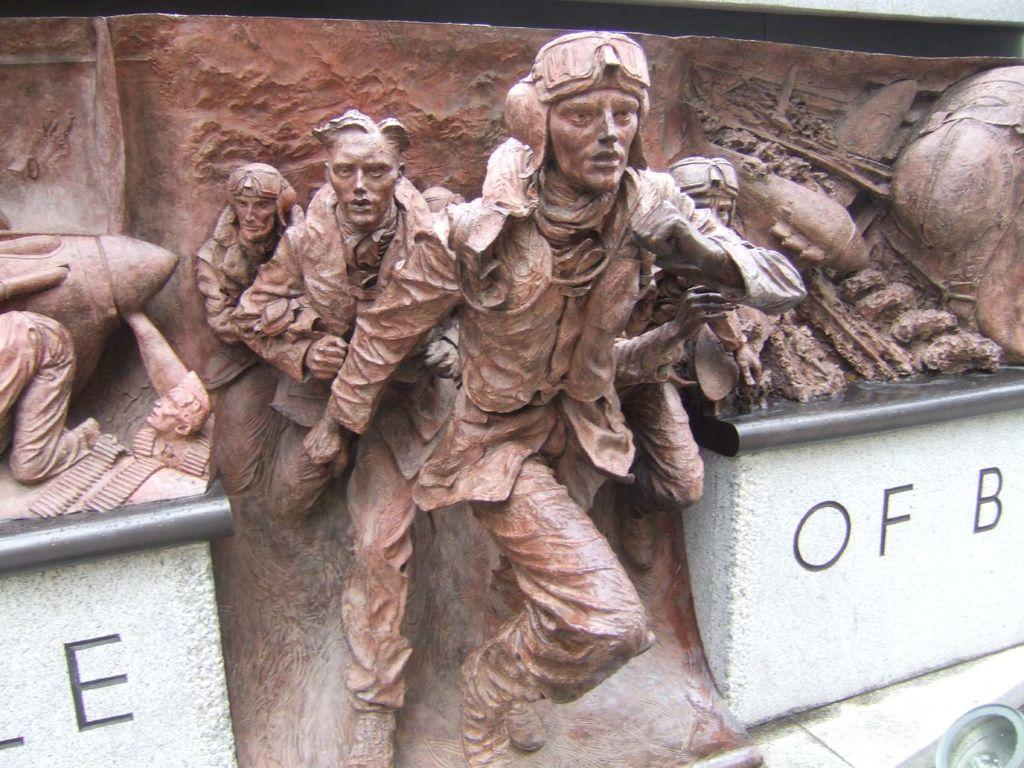What type of objects are depicted in the image? There are statues of persons in the image. What can be seen on the wall in the image? There is a wall with writing on either side in the image. Are there any other objects or features in the image? Yes, there are other objects in the right corner of the image. What type of map is being offered by the statue in the image? There is no map present in the image, nor is any statue offering anything. 